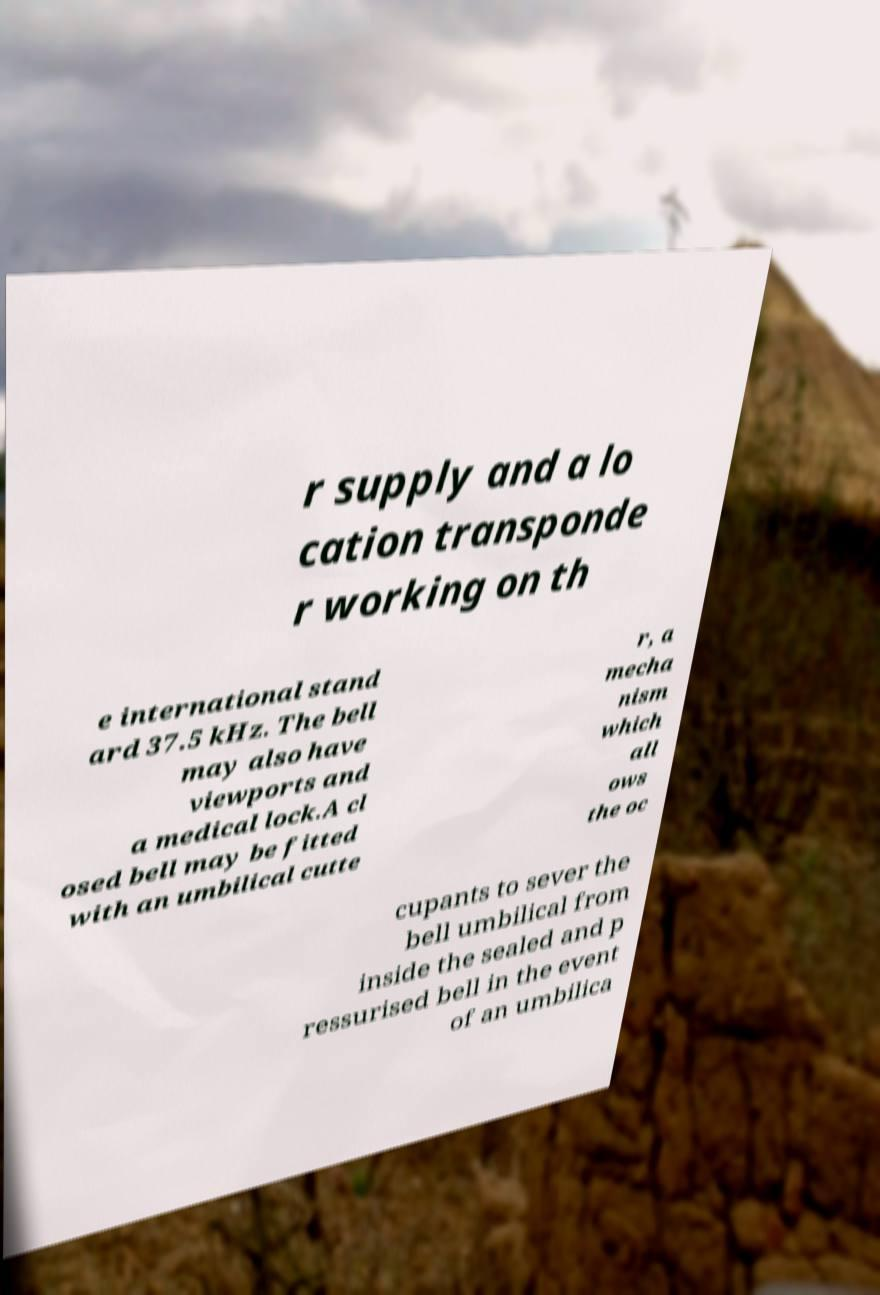Could you assist in decoding the text presented in this image and type it out clearly? r supply and a lo cation transponde r working on th e international stand ard 37.5 kHz. The bell may also have viewports and a medical lock.A cl osed bell may be fitted with an umbilical cutte r, a mecha nism which all ows the oc cupants to sever the bell umbilical from inside the sealed and p ressurised bell in the event of an umbilica 